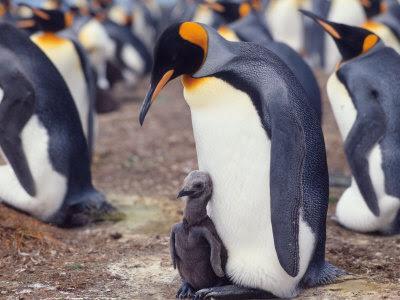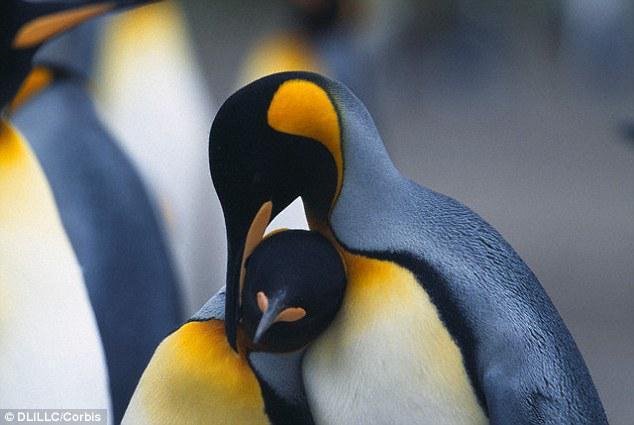The first image is the image on the left, the second image is the image on the right. For the images shown, is this caption "There are at least 4 penguins and none of them has a small baby alongside them." true? Answer yes or no. No. 